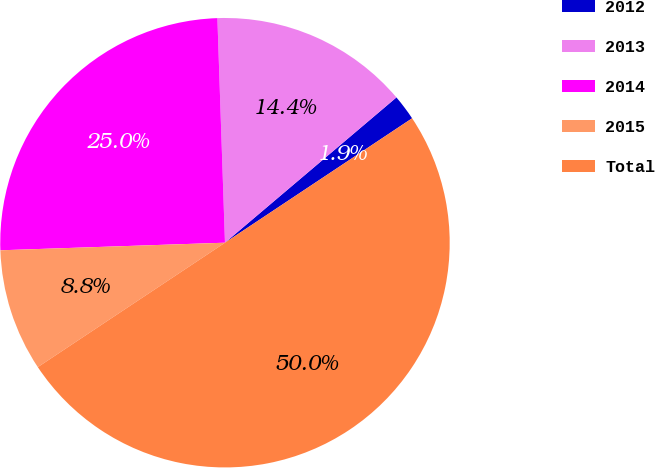Convert chart. <chart><loc_0><loc_0><loc_500><loc_500><pie_chart><fcel>2012<fcel>2013<fcel>2014<fcel>2015<fcel>Total<nl><fcel>1.85%<fcel>14.35%<fcel>25.0%<fcel>8.8%<fcel>50.0%<nl></chart> 